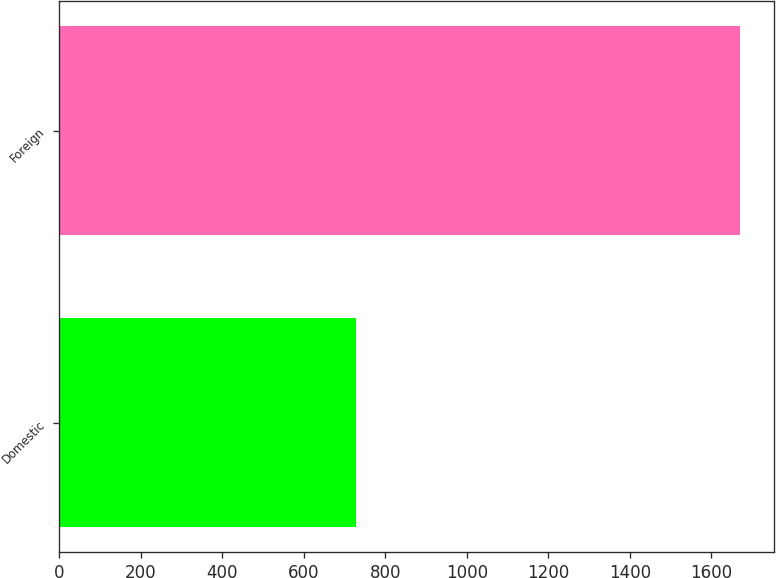<chart> <loc_0><loc_0><loc_500><loc_500><bar_chart><fcel>Domestic<fcel>Foreign<nl><fcel>727<fcel>1670<nl></chart> 